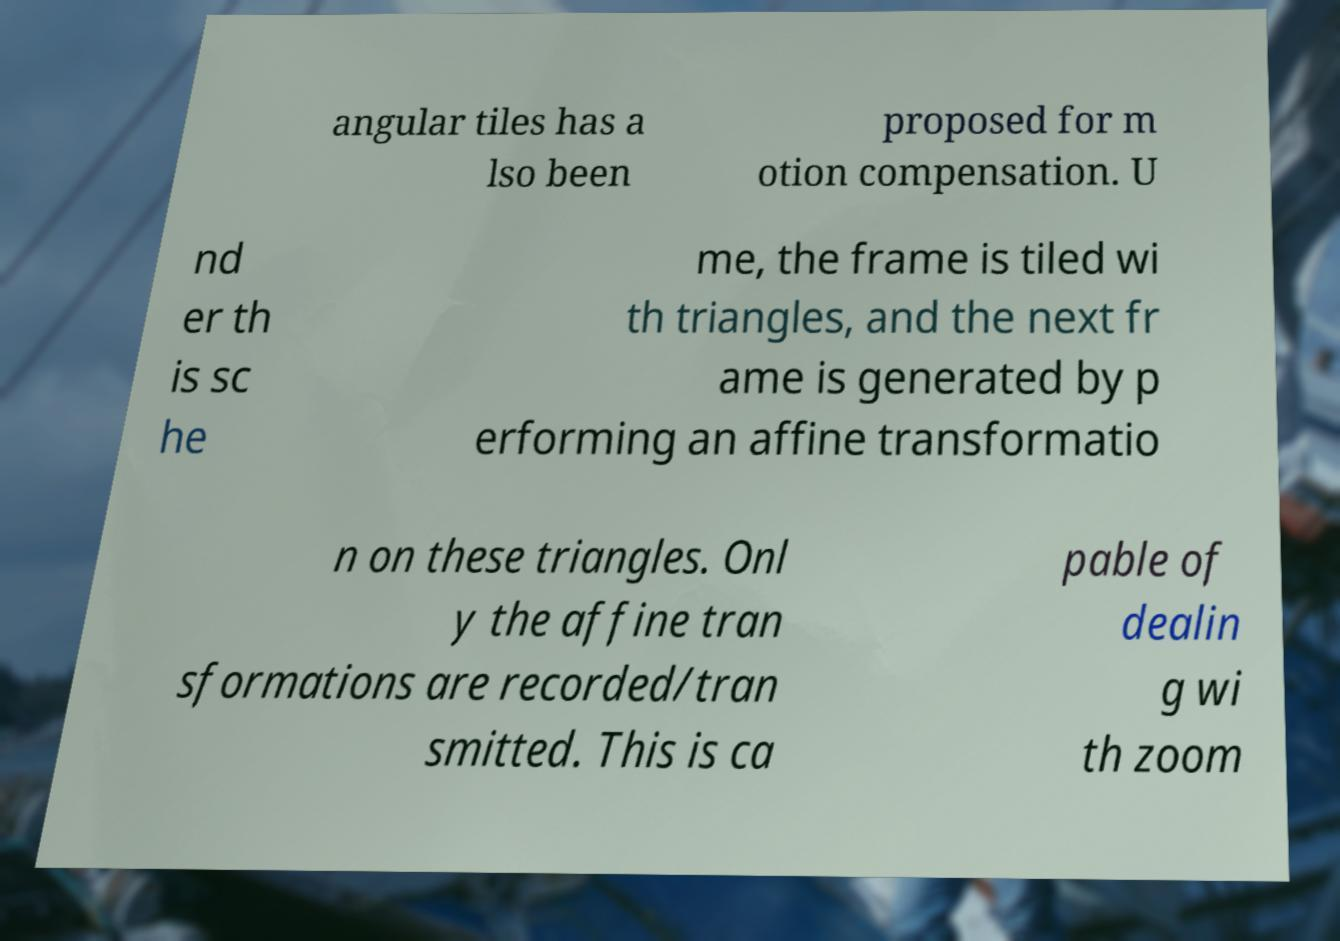Could you assist in decoding the text presented in this image and type it out clearly? angular tiles has a lso been proposed for m otion compensation. U nd er th is sc he me, the frame is tiled wi th triangles, and the next fr ame is generated by p erforming an affine transformatio n on these triangles. Onl y the affine tran sformations are recorded/tran smitted. This is ca pable of dealin g wi th zoom 